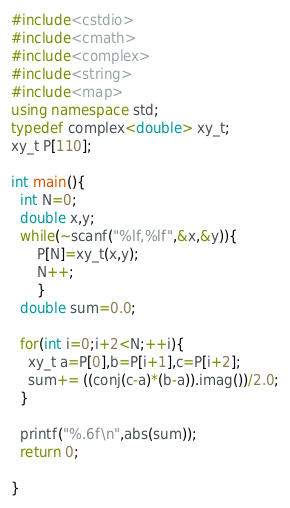Convert code to text. <code><loc_0><loc_0><loc_500><loc_500><_C++_>#include<cstdio>
#include<cmath>
#include<complex>
#include<string>
#include<map>
using namespace std;
typedef complex<double> xy_t;
xy_t P[110];

int main(){
  int N=0;
  double x,y;
  while(~scanf("%lf,%lf",&x,&y)){
      P[N]=xy_t(x,y);
      N++;
      }
  double sum=0.0;

  for(int i=0;i+2<N;++i){
    xy_t a=P[0],b=P[i+1],c=P[i+2];
    sum+= ((conj(c-a)*(b-a)).imag())/2.0;
  }

  printf("%.6f\n",abs(sum));
  return 0;

}</code> 